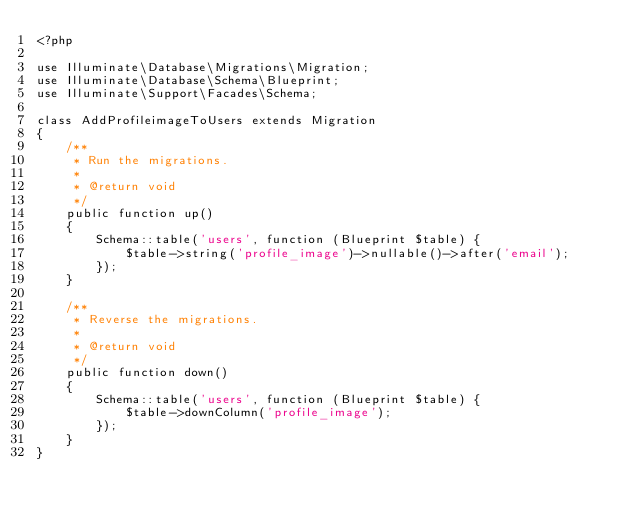Convert code to text. <code><loc_0><loc_0><loc_500><loc_500><_PHP_><?php

use Illuminate\Database\Migrations\Migration;
use Illuminate\Database\Schema\Blueprint;
use Illuminate\Support\Facades\Schema;

class AddProfileimageToUsers extends Migration
{
    /**
     * Run the migrations.
     *
     * @return void
     */
    public function up()
    {
        Schema::table('users', function (Blueprint $table) {
            $table->string('profile_image')->nullable()->after('email');
        });
    }

    /**
     * Reverse the migrations.
     *
     * @return void
     */
    public function down()
    {
        Schema::table('users', function (Blueprint $table) {
            $table->downColumn('profile_image');
        });
    }
}
</code> 